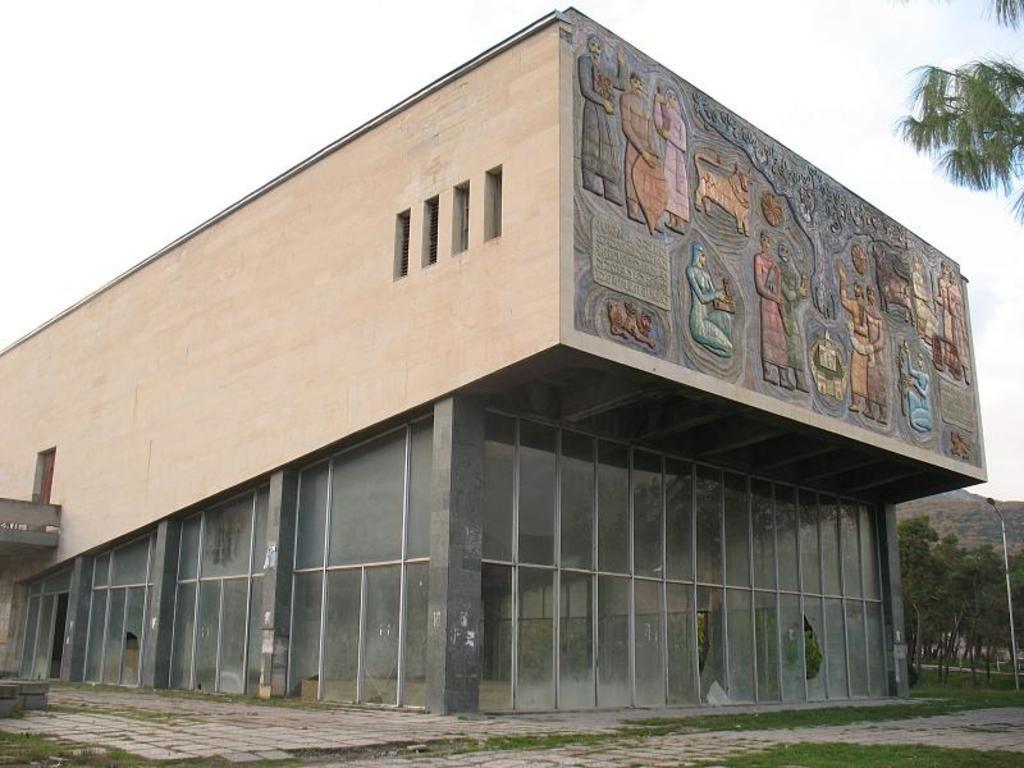Could you give a brief overview of what you see in this image? In this image I can see a building. In the background, I can see a pole and the trees. At the top I can see the sky. 